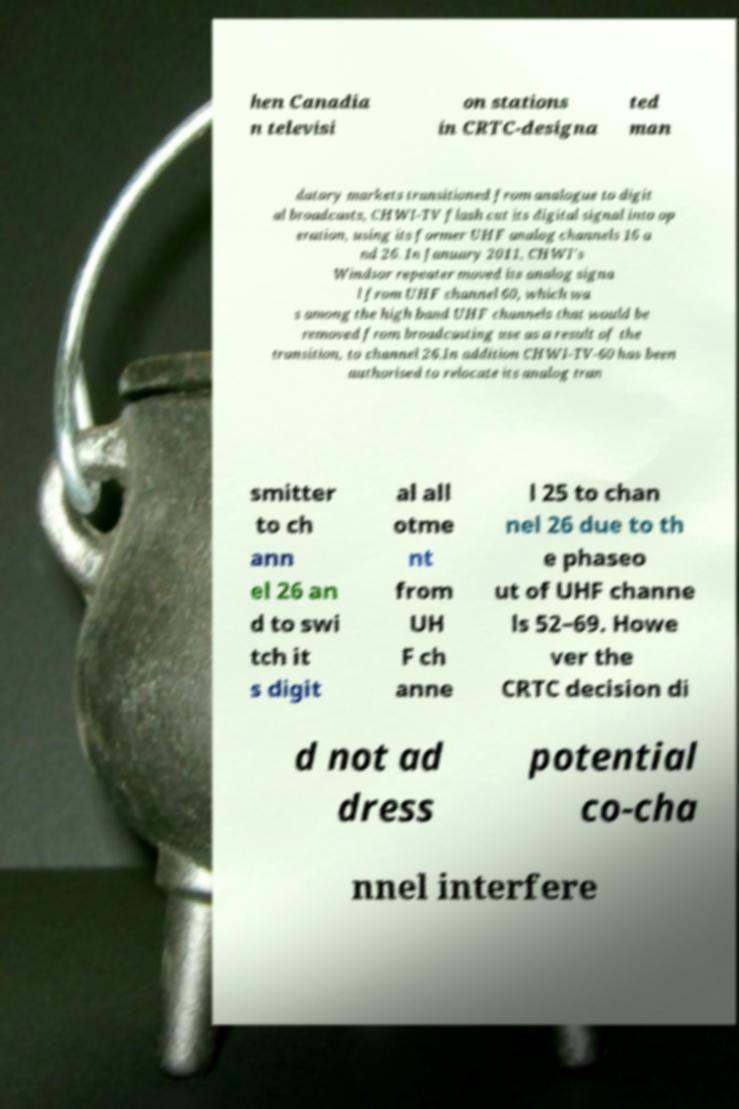Can you read and provide the text displayed in the image?This photo seems to have some interesting text. Can you extract and type it out for me? hen Canadia n televisi on stations in CRTC-designa ted man datory markets transitioned from analogue to digit al broadcasts, CHWI-TV flash cut its digital signal into op eration, using its former UHF analog channels 16 a nd 26. In January 2011, CHWI's Windsor repeater moved its analog signa l from UHF channel 60, which wa s among the high band UHF channels that would be removed from broadcasting use as a result of the transition, to channel 26.In addition CHWI-TV-60 has been authorised to relocate its analog tran smitter to ch ann el 26 an d to swi tch it s digit al all otme nt from UH F ch anne l 25 to chan nel 26 due to th e phaseo ut of UHF channe ls 52–69. Howe ver the CRTC decision di d not ad dress potential co-cha nnel interfere 